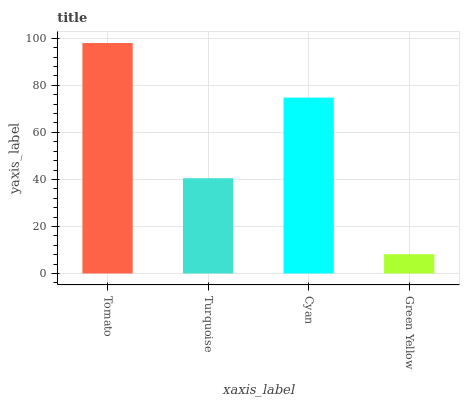Is Turquoise the minimum?
Answer yes or no. No. Is Turquoise the maximum?
Answer yes or no. No. Is Tomato greater than Turquoise?
Answer yes or no. Yes. Is Turquoise less than Tomato?
Answer yes or no. Yes. Is Turquoise greater than Tomato?
Answer yes or no. No. Is Tomato less than Turquoise?
Answer yes or no. No. Is Cyan the high median?
Answer yes or no. Yes. Is Turquoise the low median?
Answer yes or no. Yes. Is Tomato the high median?
Answer yes or no. No. Is Cyan the low median?
Answer yes or no. No. 